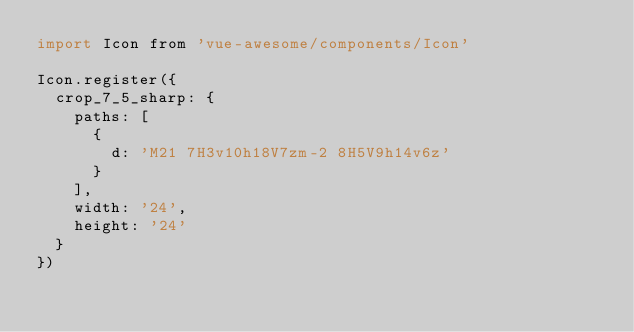Convert code to text. <code><loc_0><loc_0><loc_500><loc_500><_JavaScript_>import Icon from 'vue-awesome/components/Icon'

Icon.register({
  crop_7_5_sharp: {
    paths: [
      {
        d: 'M21 7H3v10h18V7zm-2 8H5V9h14v6z'
      }
    ],
    width: '24',
    height: '24'
  }
})
</code> 